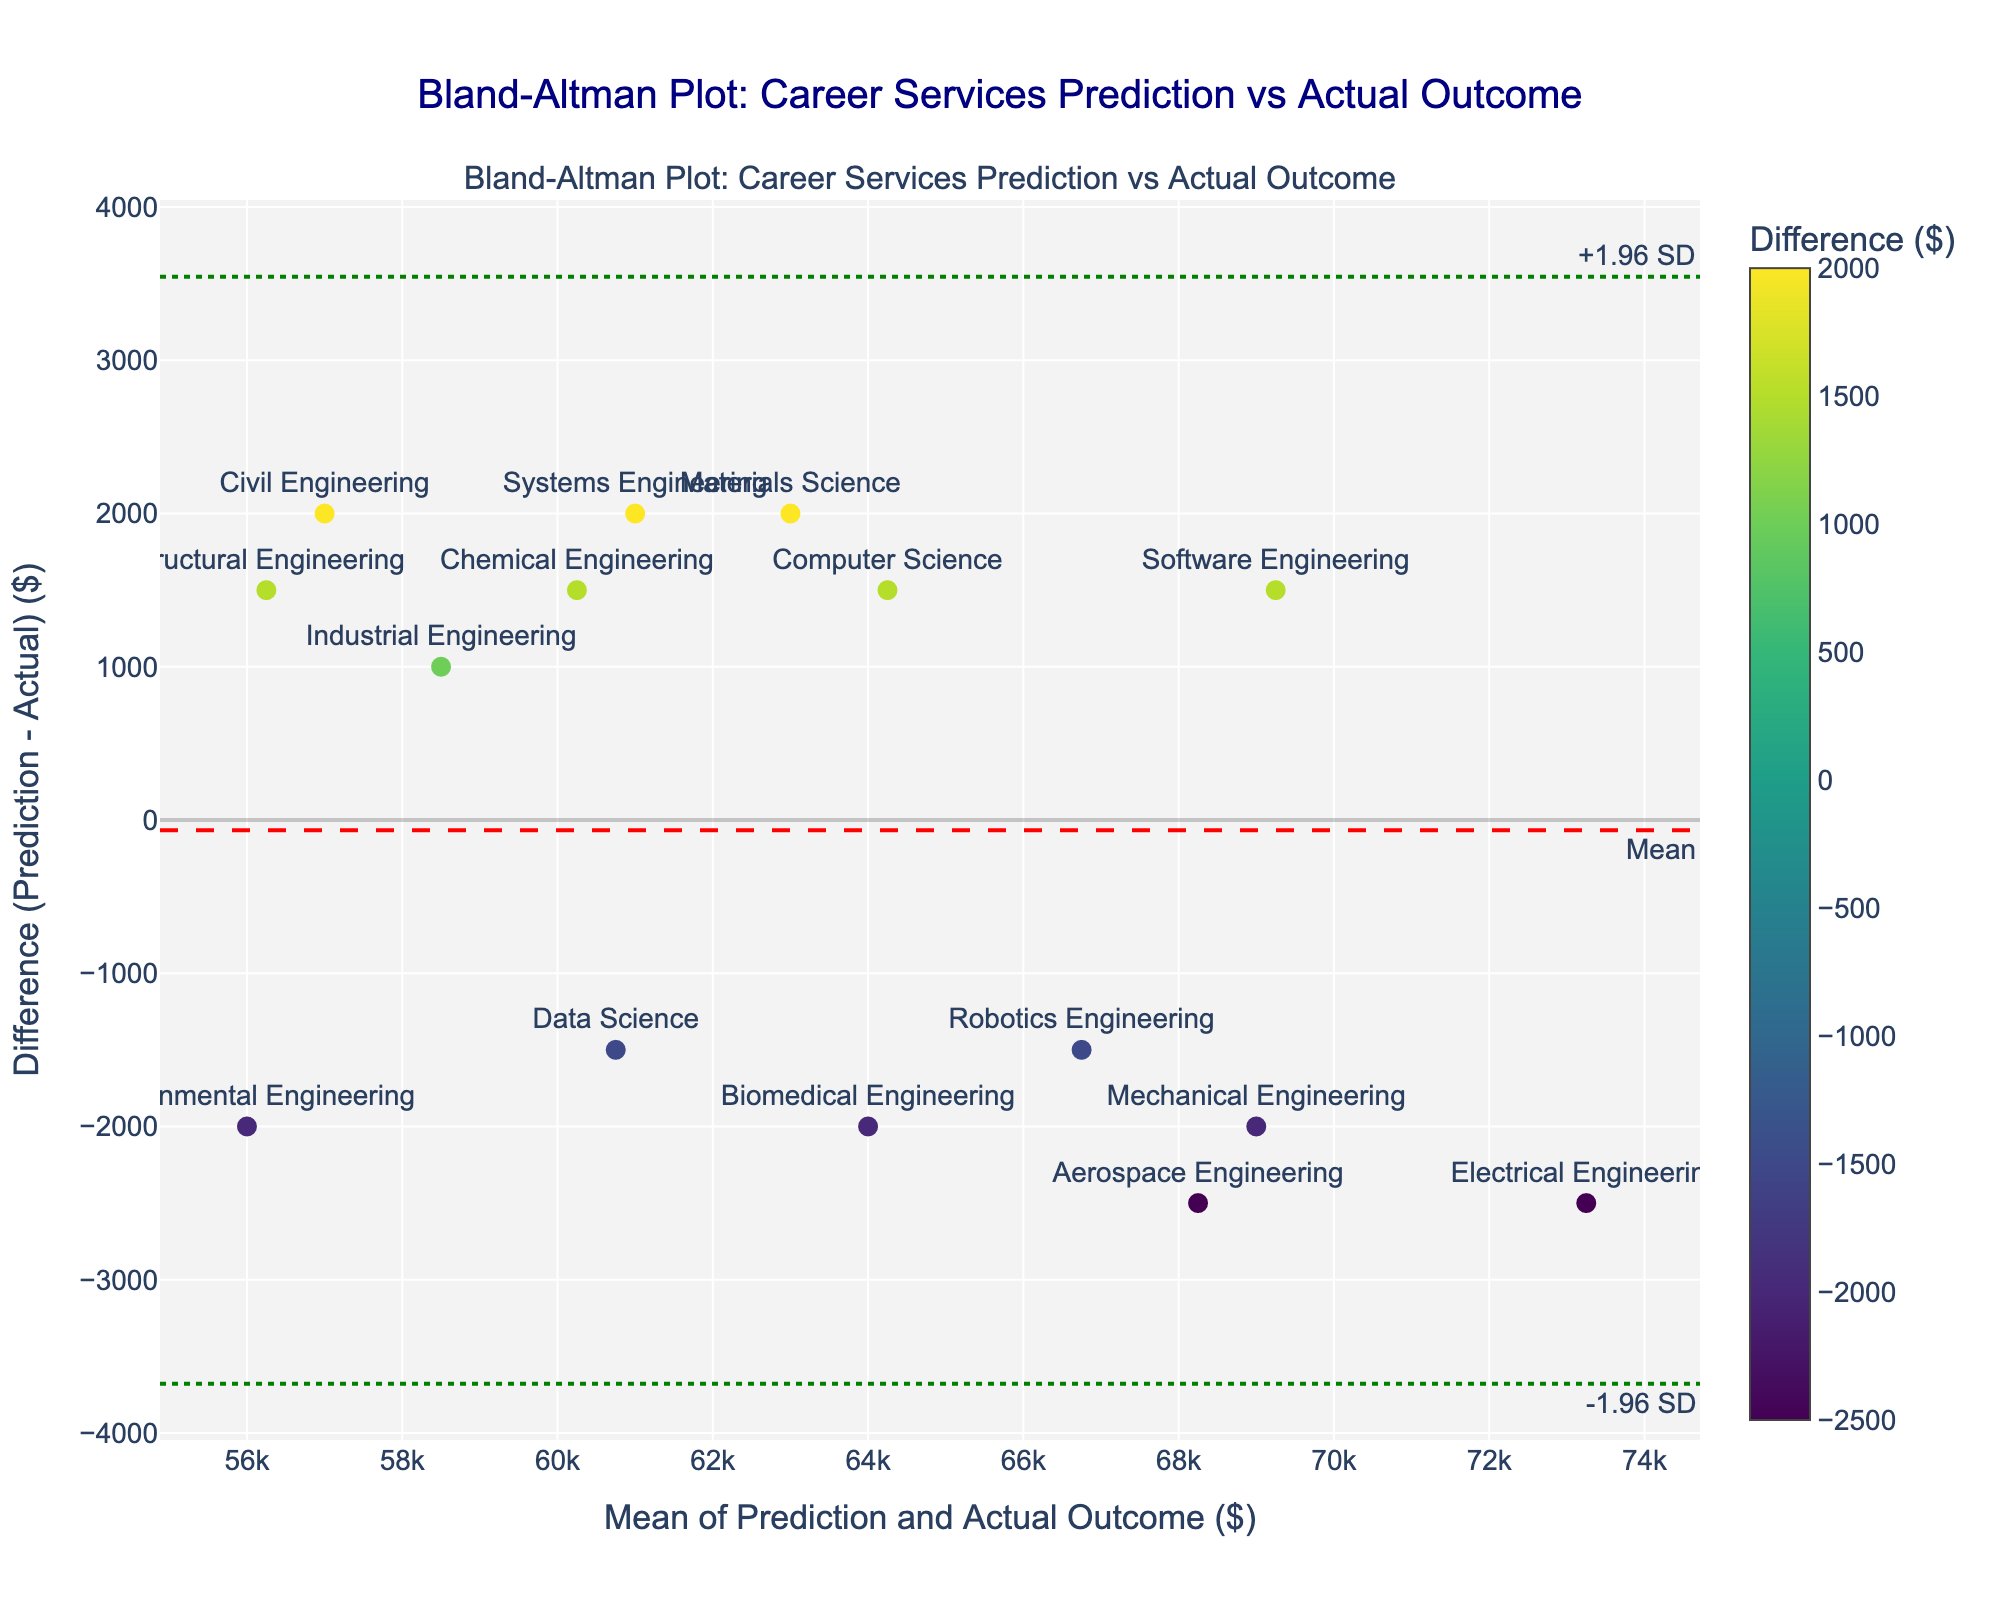How many engineering majors are represented in the plot? Each point on the plot represents a student from a specific engineering major. The plot legend shows the different majors, and counting them gives a total of 15 different engineering majors.
Answer: 15 What is the title of the plot? The title is displayed prominently at the top center of the plot.
Answer: Bland-Altman Plot: Career Services Prediction vs Actual Outcome What is the mean difference between career services predictions and actual outcomes? The mean difference is indicated by a dashed red line on the plot, with an annotation "Mean" in the bottom right.
Answer: Approximately 67 Are there any majors where career services predictions were significantly higher than actual outcomes? Data points above the mean difference (red dashed line) show instances where predictions were higher. Higher data points, especially those above the +1.96 SD green line, indicate significant differences.
Answer: Electrical Engineering Which major has the lowest mean salary? The mean salary is displayed along the x-axis. By identifying the lowest x-value with its corresponding marker, we find the lowest mean salary.
Answer: Structural Engineering What are the limits of agreement in this plot? The limits of agreement are shown as two green dotted lines, annotated as +1.96 SD and -1.96 SD. These lines mark the range within which most differences lie.
Answer: +2218.56 and -2084.56 Which major shows the smallest deviation between predicted and actual outcomes? The smallest deviation will be closest to the mean difference (red dashed line) irrespective of its mean value. Locate the point nearest to the red line without significant deviation.
Answer: Civil Engineering Based on the plot, are career services predictions generally higher or lower than actual outcomes? If most data points are above the zero line (x-axis), predictions are generally higher than actual; if below, they are generally lower. Evaluate the spread of points relative to this line.
Answer: Generally higher Does the plot indicate any major with close alignment between predicted and actual salaries? Points that align closely to the zero difference line on the y-axis show close alignment between predictions and actual outcomes. Identify majors close to this horizontal zero line.
Answer: Environmental Engineering 